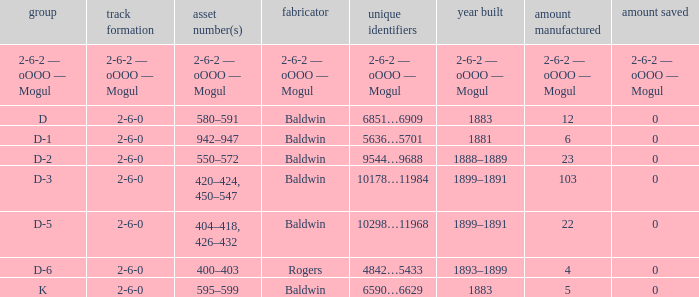What is the year made when the manufacturer is 2-6-2 — oooo — mogul? 2-6-2 — oOOO — Mogul. 